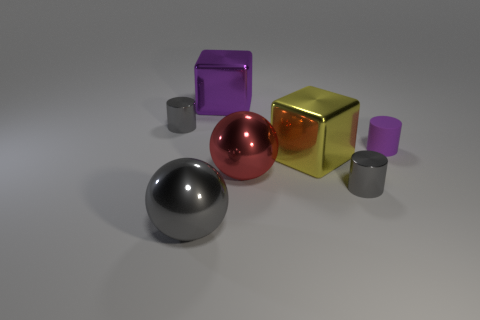Add 3 small metallic cylinders. How many objects exist? 10 Subtract all balls. How many objects are left? 5 Add 5 big gray things. How many big gray things exist? 6 Subtract 0 yellow balls. How many objects are left? 7 Subtract all large purple rubber things. Subtract all shiny blocks. How many objects are left? 5 Add 6 big objects. How many big objects are left? 10 